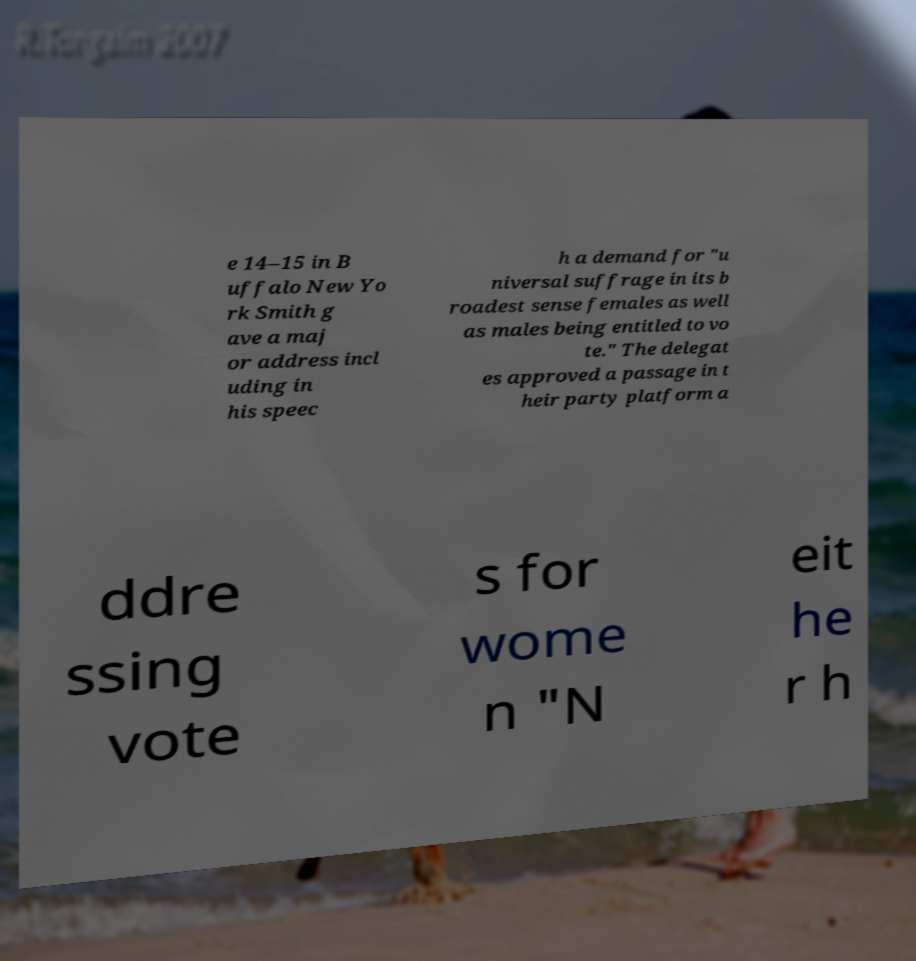For documentation purposes, I need the text within this image transcribed. Could you provide that? e 14–15 in B uffalo New Yo rk Smith g ave a maj or address incl uding in his speec h a demand for "u niversal suffrage in its b roadest sense females as well as males being entitled to vo te." The delegat es approved a passage in t heir party platform a ddre ssing vote s for wome n "N eit he r h 